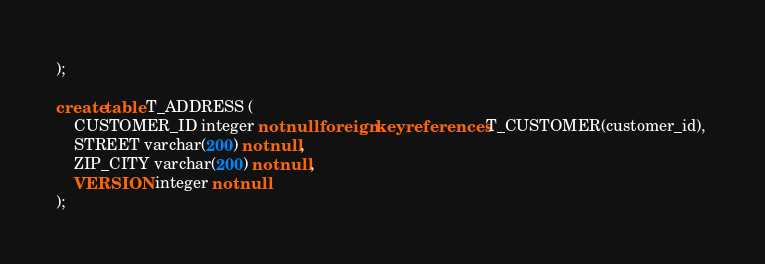Convert code to text. <code><loc_0><loc_0><loc_500><loc_500><_SQL_>);

create table T_ADDRESS (
    CUSTOMER_ID integer not null foreign key references T_CUSTOMER(customer_id), 
    STREET varchar(200) not null,
    ZIP_CITY varchar(200) not null,
    VERSION integer not null
);</code> 